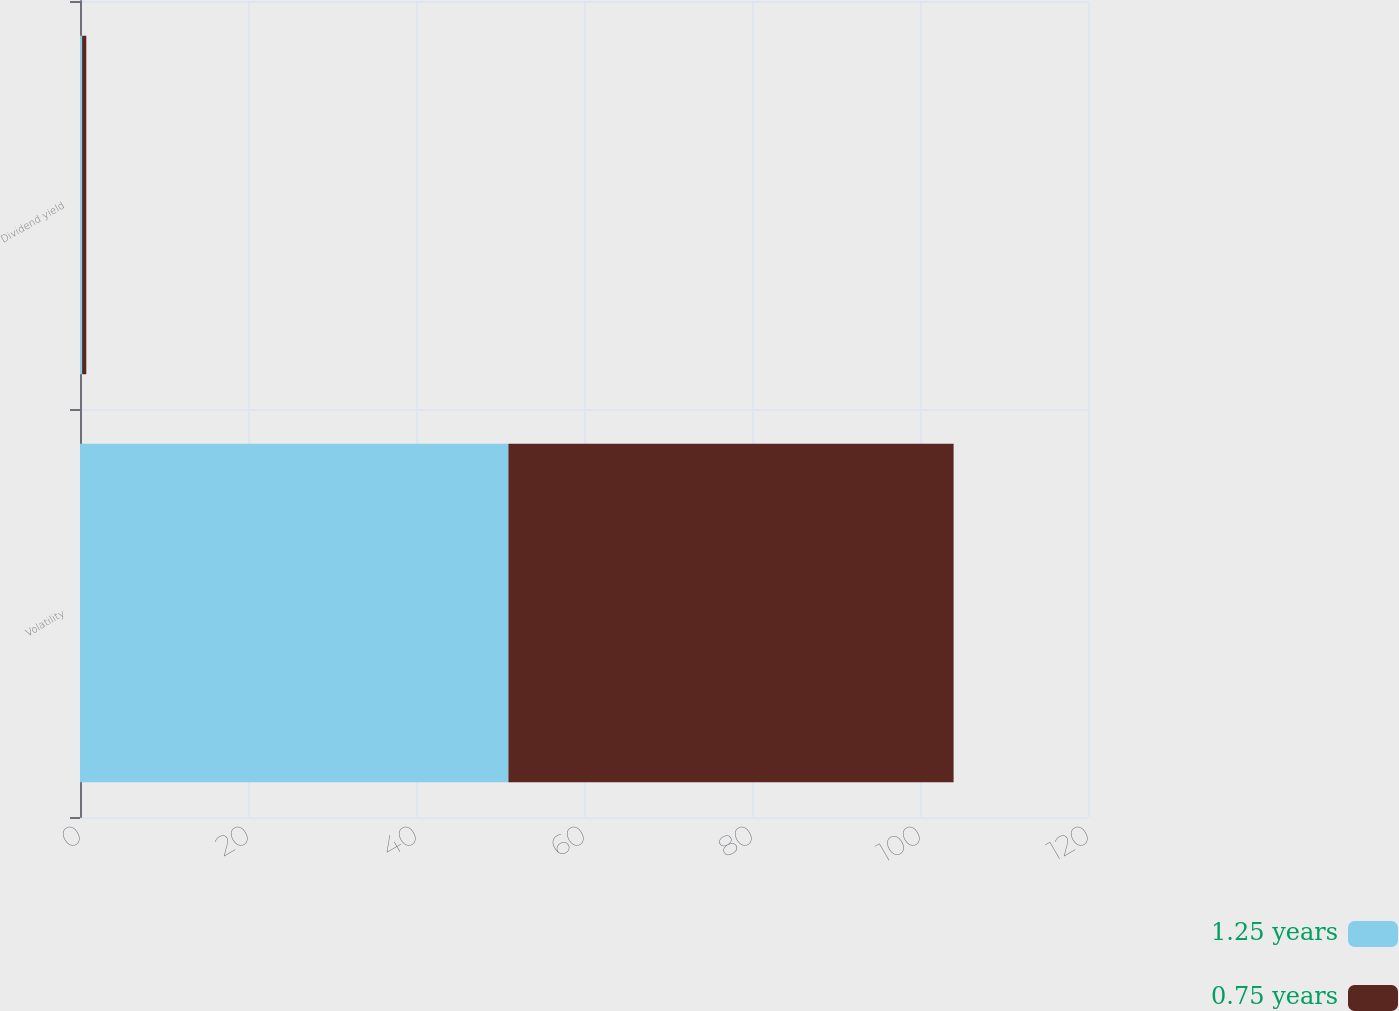Convert chart. <chart><loc_0><loc_0><loc_500><loc_500><stacked_bar_chart><ecel><fcel>Volatility<fcel>Dividend yield<nl><fcel>1.25 years<fcel>51<fcel>0.25<nl><fcel>0.75 years<fcel>53<fcel>0.5<nl></chart> 